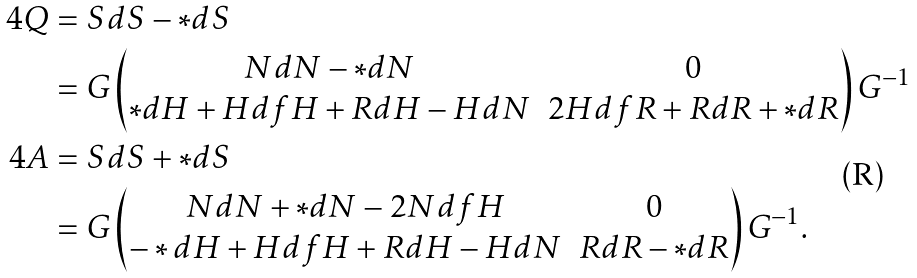Convert formula to latex. <formula><loc_0><loc_0><loc_500><loc_500>4 Q & = S d S - * d S \\ & = G \begin{pmatrix} N d N - * d N & 0 \\ * d H + H d f H + R d H - H d N & 2 H d f R + R d R + * d R \end{pmatrix} G ^ { - 1 } \\ 4 A & = S d S + * d S \\ & = G \begin{pmatrix} N d N + * d N - 2 N d f H & 0 \\ - * d H + H d f H + R d H - H d N & R d R - * d R \end{pmatrix} G ^ { - 1 } .</formula> 